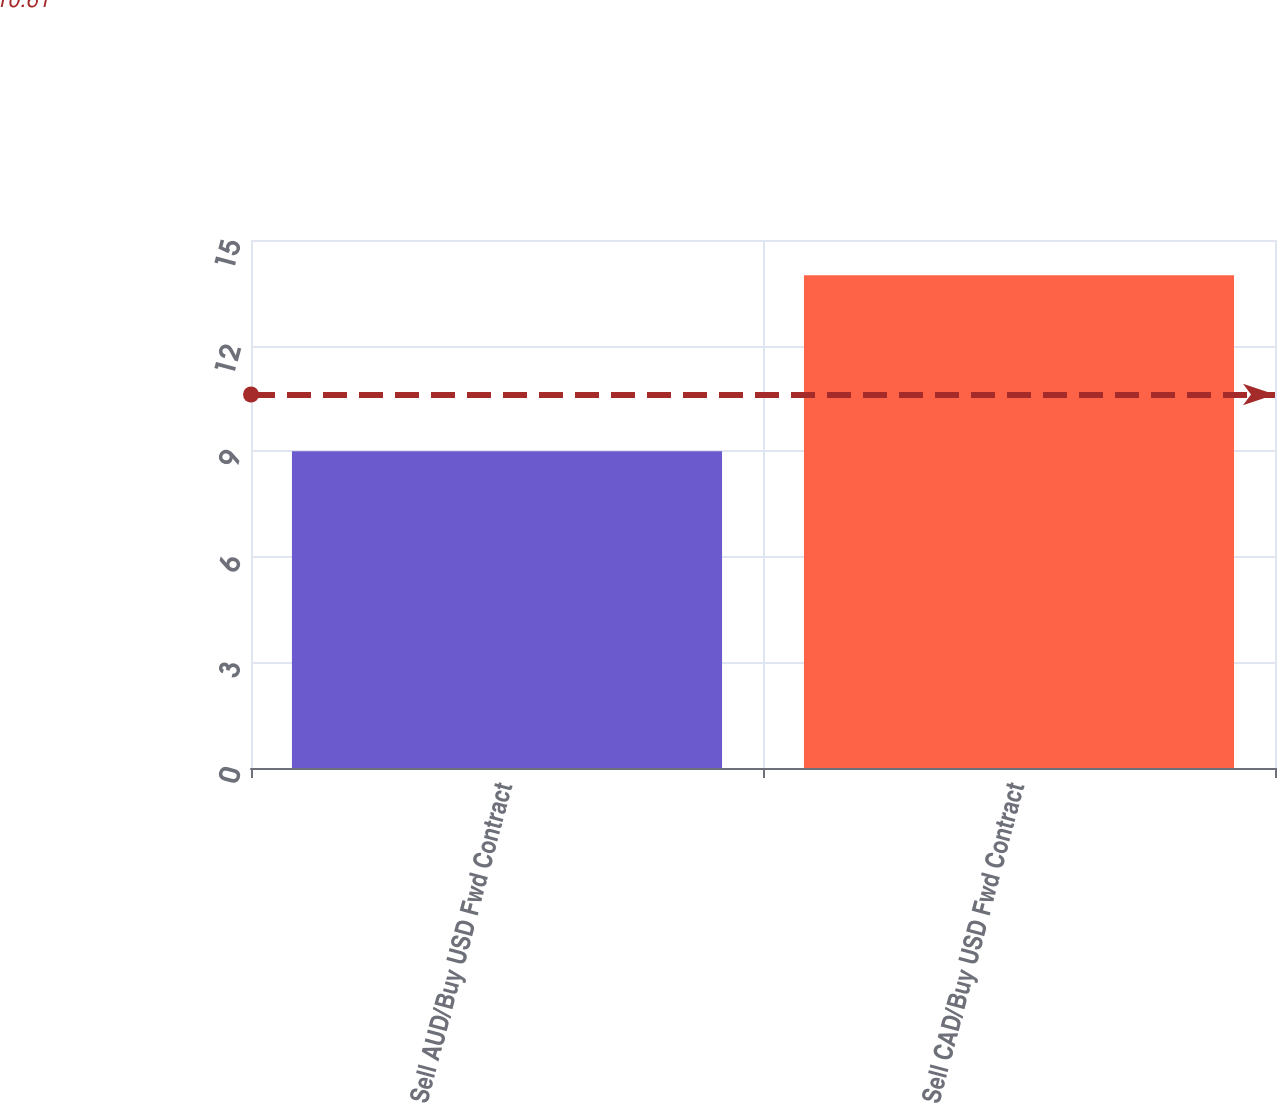Convert chart to OTSL. <chart><loc_0><loc_0><loc_500><loc_500><bar_chart><fcel>Sell AUD/Buy USD Fwd Contract<fcel>Sell CAD/Buy USD Fwd Contract<nl><fcel>9<fcel>14<nl></chart> 